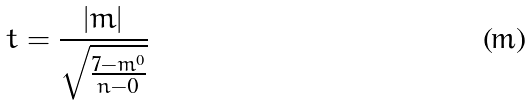Convert formula to latex. <formula><loc_0><loc_0><loc_500><loc_500>t = \frac { | m | } { \sqrt { \frac { 7 - m ^ { 0 } } { n - 0 } } }</formula> 